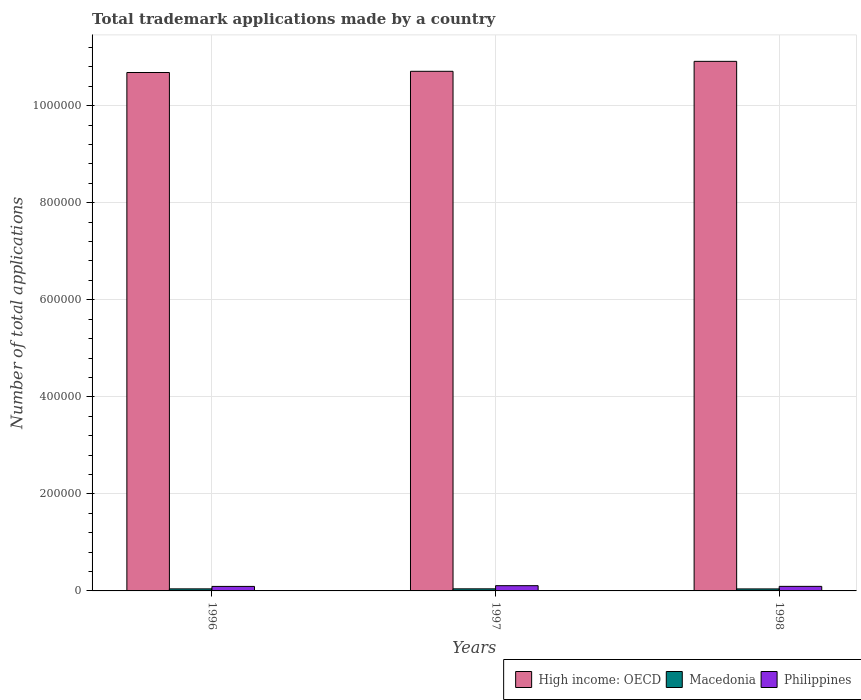How many groups of bars are there?
Your answer should be compact. 3. Are the number of bars per tick equal to the number of legend labels?
Keep it short and to the point. Yes. Are the number of bars on each tick of the X-axis equal?
Offer a very short reply. Yes. How many bars are there on the 3rd tick from the left?
Your response must be concise. 3. How many bars are there on the 3rd tick from the right?
Provide a succinct answer. 3. What is the label of the 3rd group of bars from the left?
Keep it short and to the point. 1998. What is the number of applications made by in High income: OECD in 1996?
Ensure brevity in your answer.  1.07e+06. Across all years, what is the maximum number of applications made by in Macedonia?
Your answer should be compact. 4304. Across all years, what is the minimum number of applications made by in Macedonia?
Make the answer very short. 4139. In which year was the number of applications made by in Philippines minimum?
Make the answer very short. 1996. What is the total number of applications made by in High income: OECD in the graph?
Ensure brevity in your answer.  3.23e+06. What is the difference between the number of applications made by in High income: OECD in 1997 and that in 1998?
Your response must be concise. -2.05e+04. What is the difference between the number of applications made by in Macedonia in 1997 and the number of applications made by in High income: OECD in 1996?
Your answer should be compact. -1.06e+06. What is the average number of applications made by in Macedonia per year?
Provide a succinct answer. 4229. In the year 1997, what is the difference between the number of applications made by in Macedonia and number of applications made by in Philippines?
Your answer should be very brief. -6514. What is the ratio of the number of applications made by in Philippines in 1996 to that in 1998?
Provide a succinct answer. 0.99. Is the difference between the number of applications made by in Macedonia in 1996 and 1998 greater than the difference between the number of applications made by in Philippines in 1996 and 1998?
Your response must be concise. Yes. What is the difference between the highest and the second highest number of applications made by in High income: OECD?
Your answer should be compact. 2.05e+04. What is the difference between the highest and the lowest number of applications made by in High income: OECD?
Make the answer very short. 2.30e+04. In how many years, is the number of applications made by in Philippines greater than the average number of applications made by in Philippines taken over all years?
Your answer should be compact. 1. What does the 1st bar from the left in 1996 represents?
Your answer should be compact. High income: OECD. What does the 2nd bar from the right in 1996 represents?
Provide a succinct answer. Macedonia. Is it the case that in every year, the sum of the number of applications made by in Macedonia and number of applications made by in Philippines is greater than the number of applications made by in High income: OECD?
Your response must be concise. No. How many bars are there?
Give a very brief answer. 9. Are the values on the major ticks of Y-axis written in scientific E-notation?
Provide a succinct answer. No. Does the graph contain grids?
Your answer should be very brief. Yes. How are the legend labels stacked?
Your answer should be compact. Horizontal. What is the title of the graph?
Provide a succinct answer. Total trademark applications made by a country. Does "Sub-Saharan Africa (developing only)" appear as one of the legend labels in the graph?
Ensure brevity in your answer.  No. What is the label or title of the Y-axis?
Keep it short and to the point. Number of total applications. What is the Number of total applications of High income: OECD in 1996?
Provide a succinct answer. 1.07e+06. What is the Number of total applications in Macedonia in 1996?
Provide a short and direct response. 4244. What is the Number of total applications of Philippines in 1996?
Keep it short and to the point. 9283. What is the Number of total applications of High income: OECD in 1997?
Your response must be concise. 1.07e+06. What is the Number of total applications in Macedonia in 1997?
Provide a succinct answer. 4304. What is the Number of total applications of Philippines in 1997?
Keep it short and to the point. 1.08e+04. What is the Number of total applications of High income: OECD in 1998?
Provide a succinct answer. 1.09e+06. What is the Number of total applications in Macedonia in 1998?
Offer a very short reply. 4139. What is the Number of total applications in Philippines in 1998?
Provide a short and direct response. 9401. Across all years, what is the maximum Number of total applications in High income: OECD?
Offer a terse response. 1.09e+06. Across all years, what is the maximum Number of total applications of Macedonia?
Offer a terse response. 4304. Across all years, what is the maximum Number of total applications in Philippines?
Your answer should be compact. 1.08e+04. Across all years, what is the minimum Number of total applications of High income: OECD?
Your answer should be compact. 1.07e+06. Across all years, what is the minimum Number of total applications in Macedonia?
Give a very brief answer. 4139. Across all years, what is the minimum Number of total applications in Philippines?
Your answer should be very brief. 9283. What is the total Number of total applications of High income: OECD in the graph?
Your answer should be compact. 3.23e+06. What is the total Number of total applications in Macedonia in the graph?
Keep it short and to the point. 1.27e+04. What is the total Number of total applications of Philippines in the graph?
Offer a very short reply. 2.95e+04. What is the difference between the Number of total applications in High income: OECD in 1996 and that in 1997?
Keep it short and to the point. -2472. What is the difference between the Number of total applications of Macedonia in 1996 and that in 1997?
Your answer should be very brief. -60. What is the difference between the Number of total applications of Philippines in 1996 and that in 1997?
Your answer should be very brief. -1535. What is the difference between the Number of total applications in High income: OECD in 1996 and that in 1998?
Offer a terse response. -2.30e+04. What is the difference between the Number of total applications of Macedonia in 1996 and that in 1998?
Offer a terse response. 105. What is the difference between the Number of total applications in Philippines in 1996 and that in 1998?
Your response must be concise. -118. What is the difference between the Number of total applications of High income: OECD in 1997 and that in 1998?
Offer a very short reply. -2.05e+04. What is the difference between the Number of total applications in Macedonia in 1997 and that in 1998?
Offer a terse response. 165. What is the difference between the Number of total applications in Philippines in 1997 and that in 1998?
Provide a succinct answer. 1417. What is the difference between the Number of total applications of High income: OECD in 1996 and the Number of total applications of Macedonia in 1997?
Keep it short and to the point. 1.06e+06. What is the difference between the Number of total applications of High income: OECD in 1996 and the Number of total applications of Philippines in 1997?
Provide a succinct answer. 1.06e+06. What is the difference between the Number of total applications in Macedonia in 1996 and the Number of total applications in Philippines in 1997?
Make the answer very short. -6574. What is the difference between the Number of total applications of High income: OECD in 1996 and the Number of total applications of Macedonia in 1998?
Give a very brief answer. 1.06e+06. What is the difference between the Number of total applications in High income: OECD in 1996 and the Number of total applications in Philippines in 1998?
Offer a terse response. 1.06e+06. What is the difference between the Number of total applications of Macedonia in 1996 and the Number of total applications of Philippines in 1998?
Your answer should be very brief. -5157. What is the difference between the Number of total applications of High income: OECD in 1997 and the Number of total applications of Macedonia in 1998?
Give a very brief answer. 1.07e+06. What is the difference between the Number of total applications of High income: OECD in 1997 and the Number of total applications of Philippines in 1998?
Provide a succinct answer. 1.06e+06. What is the difference between the Number of total applications in Macedonia in 1997 and the Number of total applications in Philippines in 1998?
Your answer should be very brief. -5097. What is the average Number of total applications of High income: OECD per year?
Offer a very short reply. 1.08e+06. What is the average Number of total applications of Macedonia per year?
Give a very brief answer. 4229. What is the average Number of total applications in Philippines per year?
Provide a succinct answer. 9834. In the year 1996, what is the difference between the Number of total applications in High income: OECD and Number of total applications in Macedonia?
Provide a short and direct response. 1.06e+06. In the year 1996, what is the difference between the Number of total applications in High income: OECD and Number of total applications in Philippines?
Your answer should be very brief. 1.06e+06. In the year 1996, what is the difference between the Number of total applications of Macedonia and Number of total applications of Philippines?
Provide a short and direct response. -5039. In the year 1997, what is the difference between the Number of total applications in High income: OECD and Number of total applications in Macedonia?
Keep it short and to the point. 1.07e+06. In the year 1997, what is the difference between the Number of total applications of High income: OECD and Number of total applications of Philippines?
Ensure brevity in your answer.  1.06e+06. In the year 1997, what is the difference between the Number of total applications of Macedonia and Number of total applications of Philippines?
Provide a short and direct response. -6514. In the year 1998, what is the difference between the Number of total applications of High income: OECD and Number of total applications of Macedonia?
Your answer should be compact. 1.09e+06. In the year 1998, what is the difference between the Number of total applications in High income: OECD and Number of total applications in Philippines?
Make the answer very short. 1.08e+06. In the year 1998, what is the difference between the Number of total applications of Macedonia and Number of total applications of Philippines?
Offer a terse response. -5262. What is the ratio of the Number of total applications of High income: OECD in 1996 to that in 1997?
Your answer should be compact. 1. What is the ratio of the Number of total applications in Macedonia in 1996 to that in 1997?
Provide a short and direct response. 0.99. What is the ratio of the Number of total applications in Philippines in 1996 to that in 1997?
Your answer should be very brief. 0.86. What is the ratio of the Number of total applications in High income: OECD in 1996 to that in 1998?
Provide a short and direct response. 0.98. What is the ratio of the Number of total applications in Macedonia in 1996 to that in 1998?
Make the answer very short. 1.03. What is the ratio of the Number of total applications of Philippines in 1996 to that in 1998?
Offer a terse response. 0.99. What is the ratio of the Number of total applications of High income: OECD in 1997 to that in 1998?
Keep it short and to the point. 0.98. What is the ratio of the Number of total applications in Macedonia in 1997 to that in 1998?
Make the answer very short. 1.04. What is the ratio of the Number of total applications in Philippines in 1997 to that in 1998?
Your answer should be compact. 1.15. What is the difference between the highest and the second highest Number of total applications in High income: OECD?
Offer a terse response. 2.05e+04. What is the difference between the highest and the second highest Number of total applications of Philippines?
Provide a succinct answer. 1417. What is the difference between the highest and the lowest Number of total applications of High income: OECD?
Offer a very short reply. 2.30e+04. What is the difference between the highest and the lowest Number of total applications in Macedonia?
Give a very brief answer. 165. What is the difference between the highest and the lowest Number of total applications in Philippines?
Your response must be concise. 1535. 